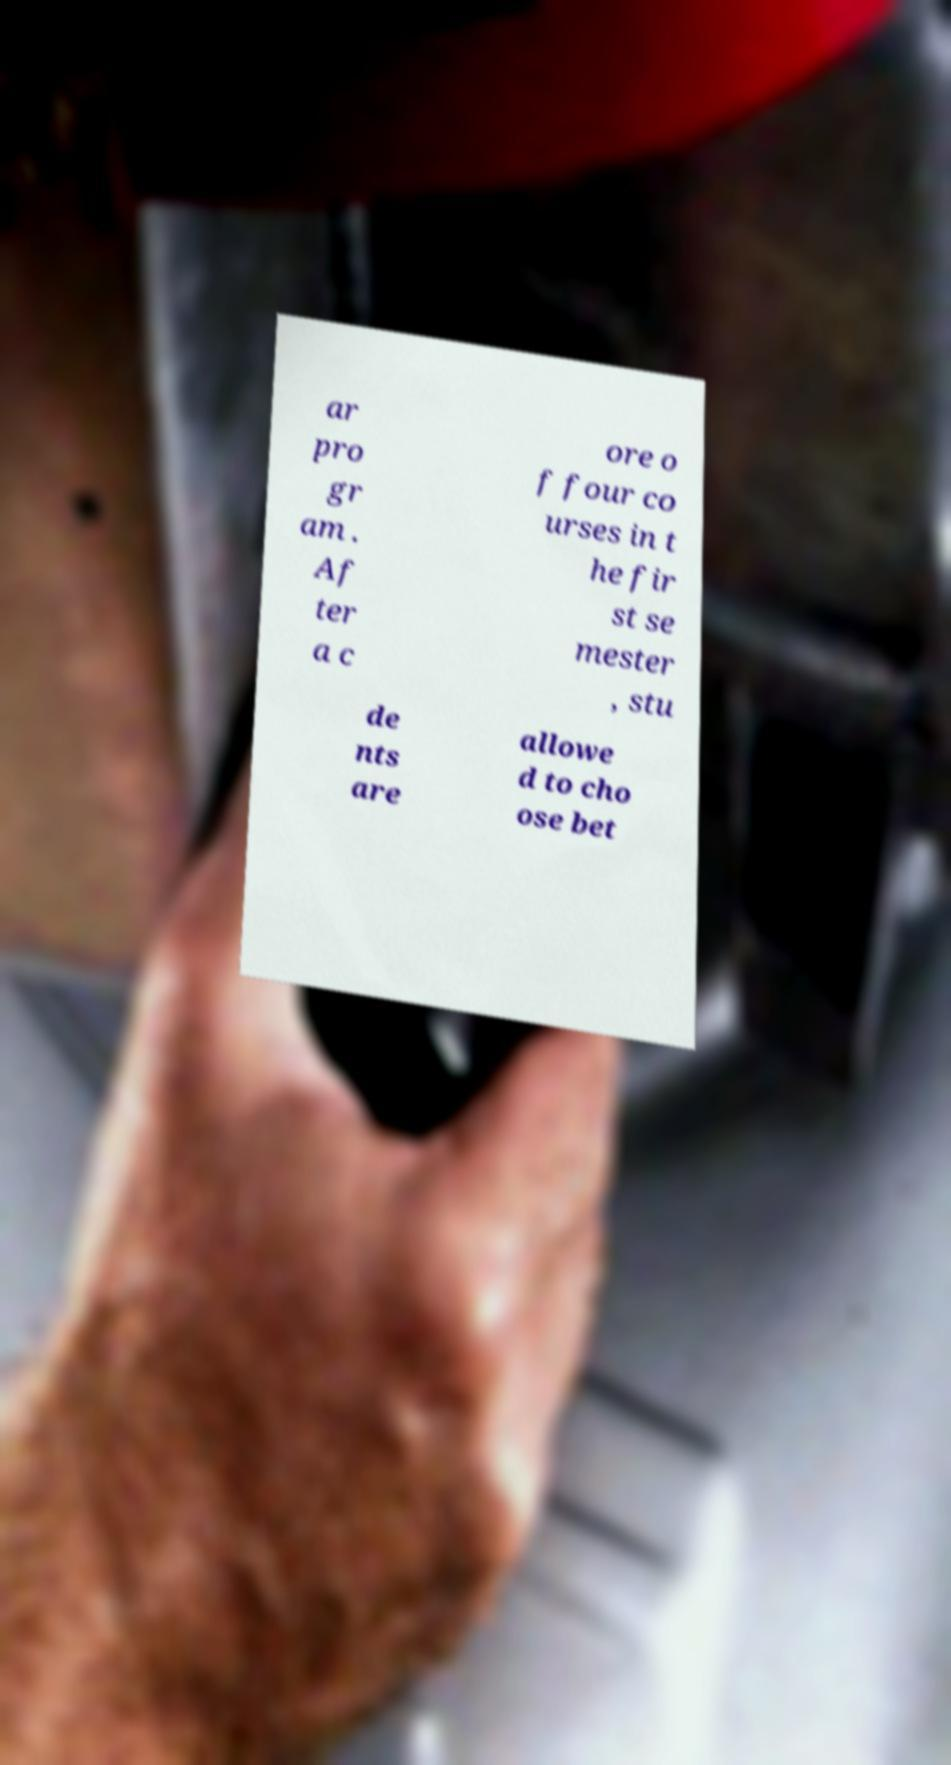Can you accurately transcribe the text from the provided image for me? ar pro gr am . Af ter a c ore o f four co urses in t he fir st se mester , stu de nts are allowe d to cho ose bet 